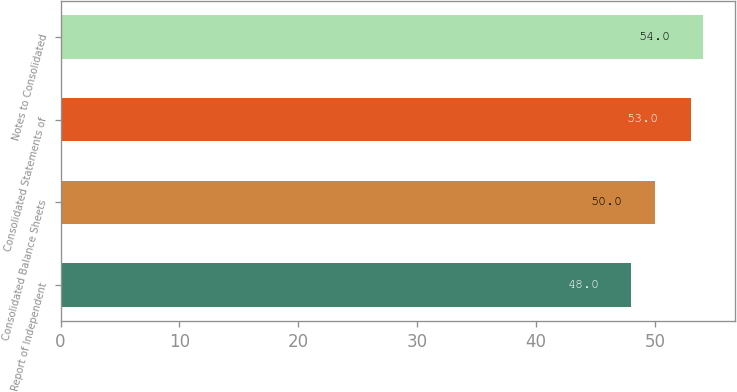Convert chart. <chart><loc_0><loc_0><loc_500><loc_500><bar_chart><fcel>Report of Independent<fcel>Consolidated Balance Sheets<fcel>Consolidated Statements of<fcel>Notes to Consolidated<nl><fcel>48<fcel>50<fcel>53<fcel>54<nl></chart> 